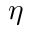<formula> <loc_0><loc_0><loc_500><loc_500>\eta</formula> 